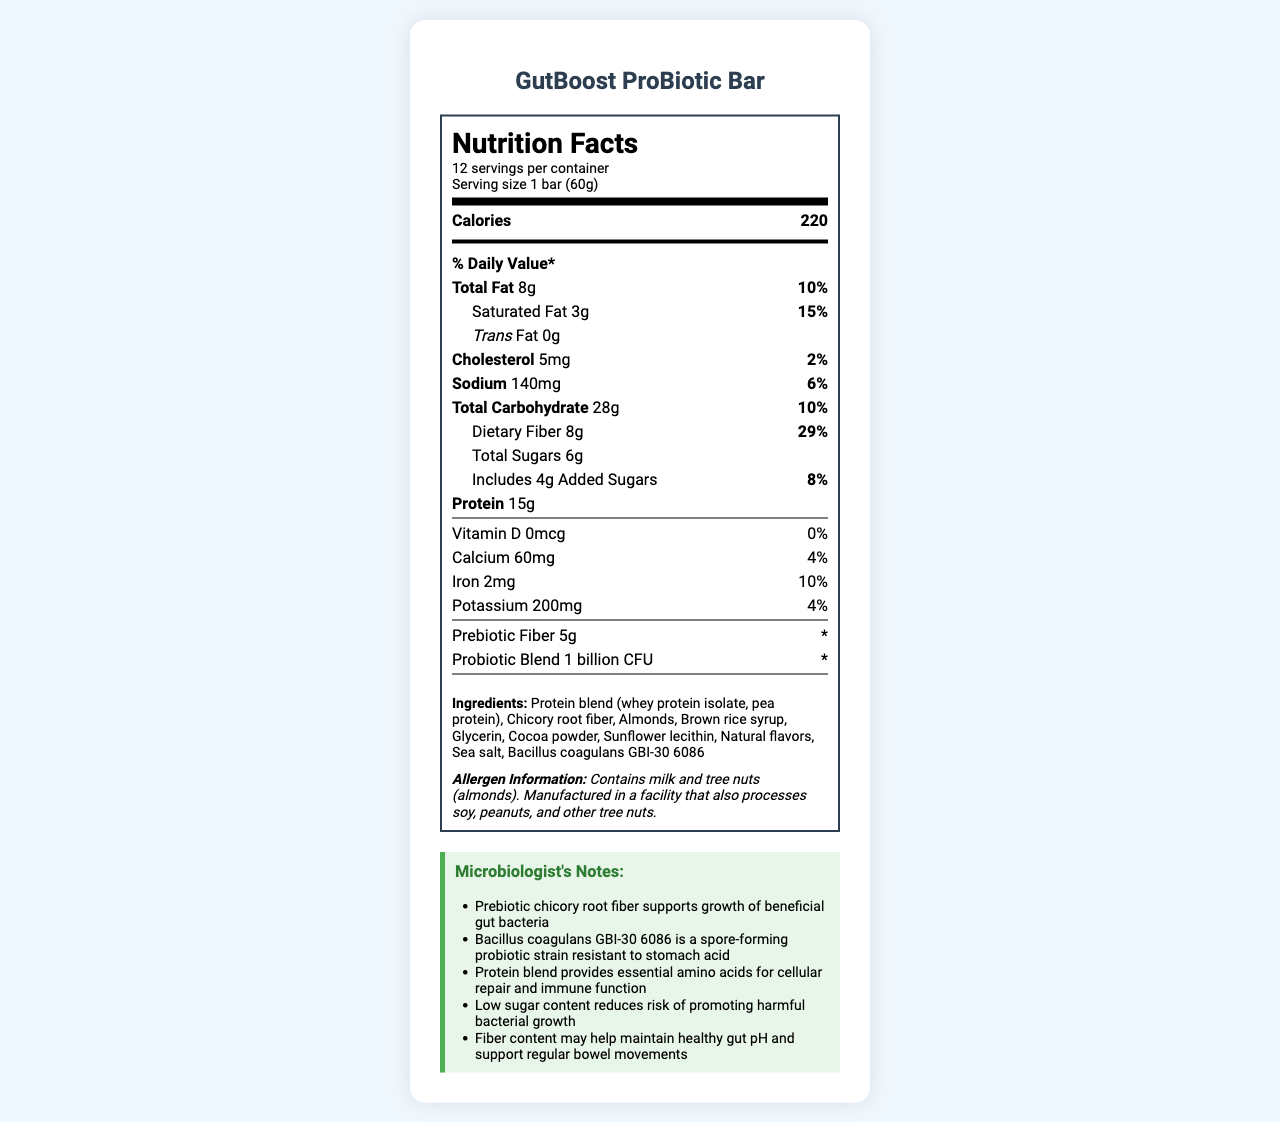how many calories are in one serving of the GutBoost ProBiotic Bar? The document states that each serving of the GutBoost ProBiotic Bar contains 220 calories.
Answer: 220 what is the serving size of the GutBoost ProBiotic Bar? The document specifies that the serving size is 1 bar, which weighs 60 grams.
Answer: 1 bar (60g) what percentage of the daily value is provided by the dietary fiber content? According to the document, the dietary fiber content provides 29% of the daily value.
Answer: 29% how much protein is in one serving of the GutBoost ProBiotic Bar? The document indicates that one serving contains 15 grams of protein.
Answer: 15g how much sodium is in one serving, and what percentage of the daily value does it represent? One serving contains 140 milligrams of sodium, which is 6% of the daily value.
Answer: 140mg, 6% what type of fiber is included in the GutBoost ProBiotic Bar? A. Pectin B. Xanthan gum C. Chicory root fiber D. Psyllium husk E. Inulin The ingredients list in the document mentions chicory root fiber.
Answer: C. Chicory root fiber which of the following is true about the probiotic blend in the GutBoost ProBiotic Bar? A. It contains 5 billion CFU B. It is a non-spore-forming strain C. It is resistant to stomach acid D. It contains Lactobacillus The document notes that the probiotic strain Bacillus coagulans GBI-30 6086 is resistant to stomach acid.
Answer: C. It is resistant to stomach acid does the GutBoost ProBiotic Bar contain any trans fat? The document states that the bar contains 0 grams of trans fat.
Answer: No describe the main elements provided in the Nutrition Facts label for the GutBoost ProBiotic Bar. The label provides a comprehensive overview of the nutritional content, ingredient list, and functional benefits observed by a microbiologist. It includes data on fats, carbohydrates, proteins, and micronutrients and highlights the unique inclusion of prebiotic fibers and probiotics.
Answer: The Nutrition Facts label includes information on the serving size, calories, macronutrient breakdown (fats, carbohydrates, protein), percentages of daily values, the amount of various micronutrients, and additional components such as prebiotic fiber and a probiotic blend. The document also lists the ingredients and allergen information, along with some notes from a microbiologist about the benefits of certain ingredients. what percentage of the daily value for calcium does the GutBoost ProBiotic Bar provide? The document mentions that the bar provides 60mg of calcium, which is 4% of the daily value.
Answer: 4% how many servings are there in one container of GutBoost ProBiotic Bars? The document states that there are 12 servings per container.
Answer: 12 servings what is the primary function of Bacillus coagulans GBI-30 6086 mentioned in the microbiologist's notes? The microbiologist's notes state that Bacillus coagulans GBI-30 6086 is a spore-forming probiotic strain resistant to stomach acid.
Answer: It is a spore-forming probiotic strain resistant to stomach acid. can you determine the exact weight of sugar in one serving of the GutBoost ProBiotic Bar? The document provides total sugars (6g) and added sugars (4g), but it does not specify the exact weight of naturally occurring sugar versus added sugar, so the exact weight of sugar alone cannot be calculated.
Answer: Cannot be determined is there any cholesterol in the GutBoost ProBiotic Bar? The document states that one serving contains 5mg of cholesterol, which is 2% of the daily value.
Answer: Yes 